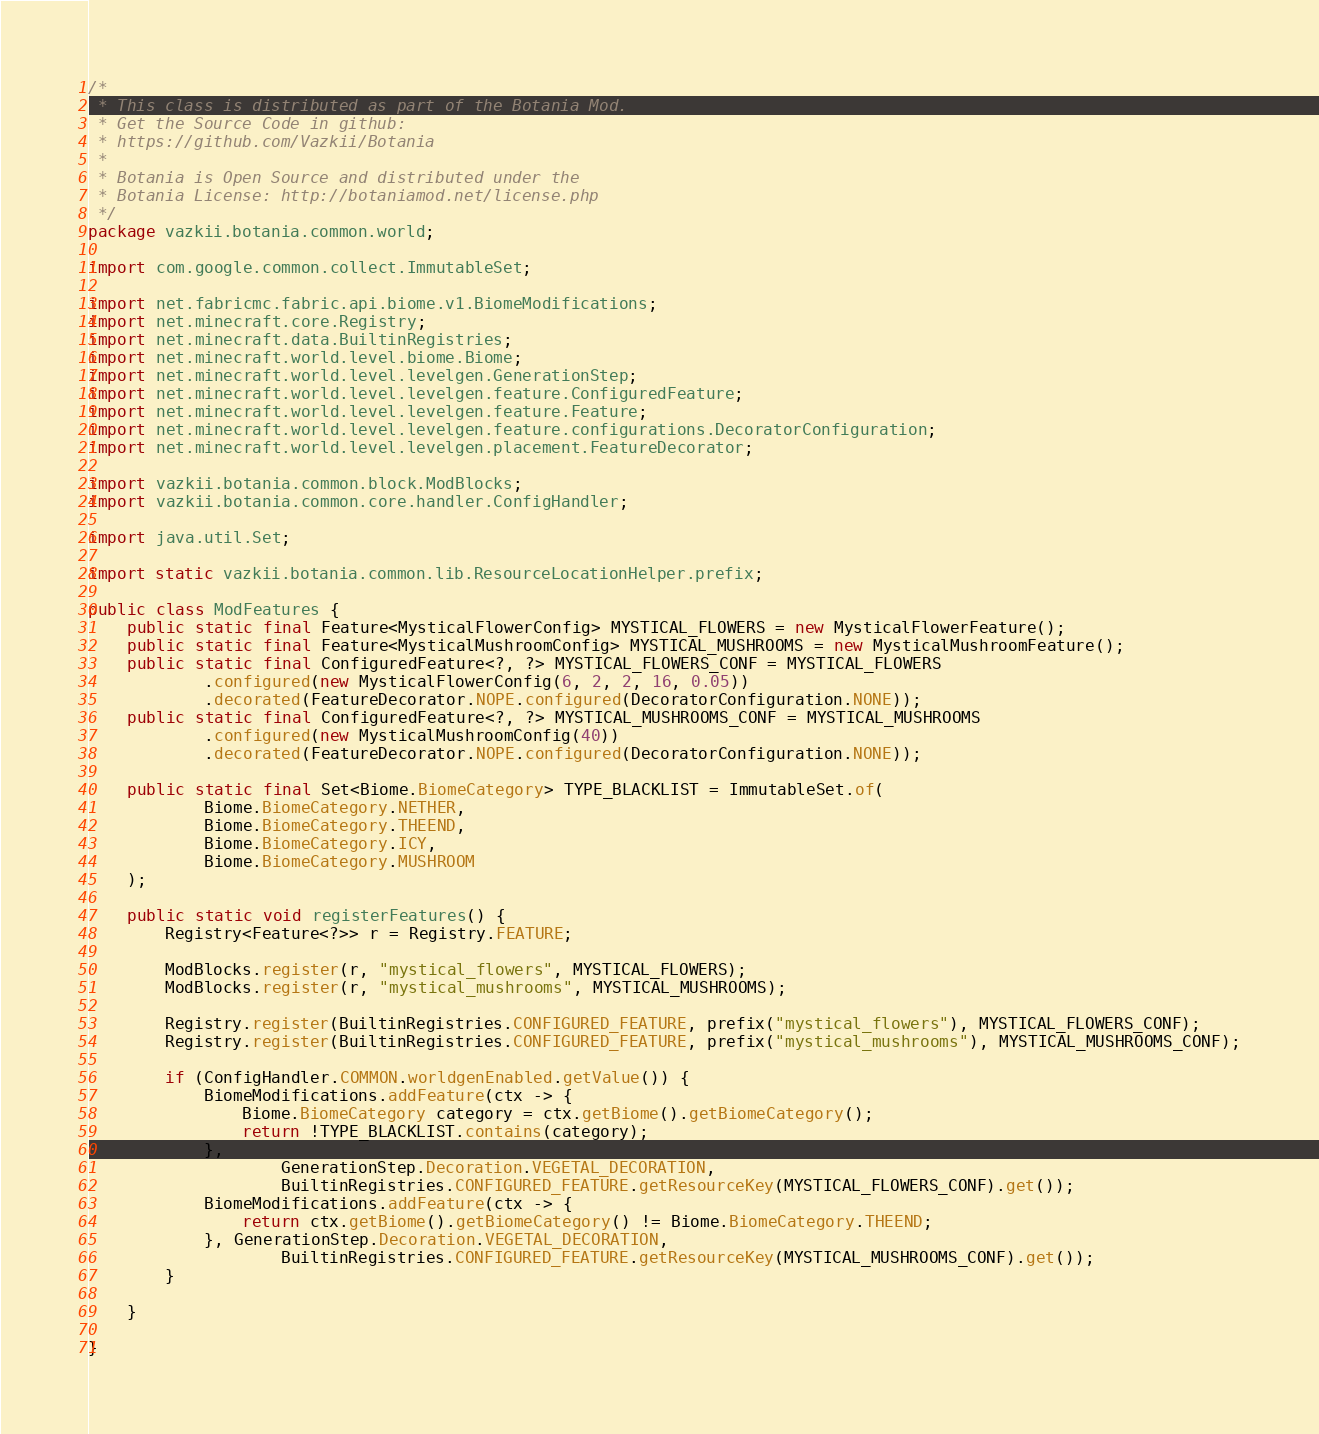<code> <loc_0><loc_0><loc_500><loc_500><_Java_>/*
 * This class is distributed as part of the Botania Mod.
 * Get the Source Code in github:
 * https://github.com/Vazkii/Botania
 *
 * Botania is Open Source and distributed under the
 * Botania License: http://botaniamod.net/license.php
 */
package vazkii.botania.common.world;

import com.google.common.collect.ImmutableSet;

import net.fabricmc.fabric.api.biome.v1.BiomeModifications;
import net.minecraft.core.Registry;
import net.minecraft.data.BuiltinRegistries;
import net.minecraft.world.level.biome.Biome;
import net.minecraft.world.level.levelgen.GenerationStep;
import net.minecraft.world.level.levelgen.feature.ConfiguredFeature;
import net.minecraft.world.level.levelgen.feature.Feature;
import net.minecraft.world.level.levelgen.feature.configurations.DecoratorConfiguration;
import net.minecraft.world.level.levelgen.placement.FeatureDecorator;

import vazkii.botania.common.block.ModBlocks;
import vazkii.botania.common.core.handler.ConfigHandler;

import java.util.Set;

import static vazkii.botania.common.lib.ResourceLocationHelper.prefix;

public class ModFeatures {
	public static final Feature<MysticalFlowerConfig> MYSTICAL_FLOWERS = new MysticalFlowerFeature();
	public static final Feature<MysticalMushroomConfig> MYSTICAL_MUSHROOMS = new MysticalMushroomFeature();
	public static final ConfiguredFeature<?, ?> MYSTICAL_FLOWERS_CONF = MYSTICAL_FLOWERS
			.configured(new MysticalFlowerConfig(6, 2, 2, 16, 0.05))
			.decorated(FeatureDecorator.NOPE.configured(DecoratorConfiguration.NONE));
	public static final ConfiguredFeature<?, ?> MYSTICAL_MUSHROOMS_CONF = MYSTICAL_MUSHROOMS
			.configured(new MysticalMushroomConfig(40))
			.decorated(FeatureDecorator.NOPE.configured(DecoratorConfiguration.NONE));

	public static final Set<Biome.BiomeCategory> TYPE_BLACKLIST = ImmutableSet.of(
			Biome.BiomeCategory.NETHER,
			Biome.BiomeCategory.THEEND,
			Biome.BiomeCategory.ICY,
			Biome.BiomeCategory.MUSHROOM
	);

	public static void registerFeatures() {
		Registry<Feature<?>> r = Registry.FEATURE;

		ModBlocks.register(r, "mystical_flowers", MYSTICAL_FLOWERS);
		ModBlocks.register(r, "mystical_mushrooms", MYSTICAL_MUSHROOMS);

		Registry.register(BuiltinRegistries.CONFIGURED_FEATURE, prefix("mystical_flowers"), MYSTICAL_FLOWERS_CONF);
		Registry.register(BuiltinRegistries.CONFIGURED_FEATURE, prefix("mystical_mushrooms"), MYSTICAL_MUSHROOMS_CONF);

		if (ConfigHandler.COMMON.worldgenEnabled.getValue()) {
			BiomeModifications.addFeature(ctx -> {
				Biome.BiomeCategory category = ctx.getBiome().getBiomeCategory();
				return !TYPE_BLACKLIST.contains(category);
			},
					GenerationStep.Decoration.VEGETAL_DECORATION,
					BuiltinRegistries.CONFIGURED_FEATURE.getResourceKey(MYSTICAL_FLOWERS_CONF).get());
			BiomeModifications.addFeature(ctx -> {
				return ctx.getBiome().getBiomeCategory() != Biome.BiomeCategory.THEEND;
			}, GenerationStep.Decoration.VEGETAL_DECORATION,
					BuiltinRegistries.CONFIGURED_FEATURE.getResourceKey(MYSTICAL_MUSHROOMS_CONF).get());
		}

	}

}
</code> 